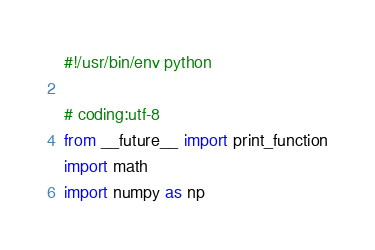<code> <loc_0><loc_0><loc_500><loc_500><_Python_>#!/usr/bin/env python

# coding:utf-8
from __future__ import print_function
import math
import numpy as np</code> 